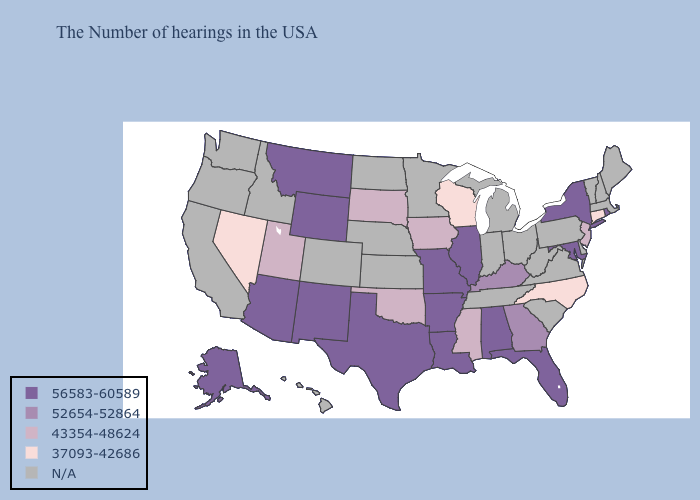Does Oklahoma have the lowest value in the South?
Short answer required. No. Does Arkansas have the highest value in the South?
Quick response, please. Yes. Name the states that have a value in the range 52654-52864?
Write a very short answer. Georgia, Kentucky. Name the states that have a value in the range N/A?
Be succinct. Maine, Massachusetts, New Hampshire, Vermont, Delaware, Pennsylvania, Virginia, South Carolina, West Virginia, Ohio, Michigan, Indiana, Tennessee, Minnesota, Kansas, Nebraska, North Dakota, Colorado, Idaho, California, Washington, Oregon, Hawaii. Name the states that have a value in the range 56583-60589?
Quick response, please. Rhode Island, New York, Maryland, Florida, Alabama, Illinois, Louisiana, Missouri, Arkansas, Texas, Wyoming, New Mexico, Montana, Arizona, Alaska. Among the states that border Alabama , which have the highest value?
Quick response, please. Florida. Name the states that have a value in the range 37093-42686?
Keep it brief. Connecticut, North Carolina, Wisconsin, Nevada. What is the lowest value in states that border Florida?
Keep it brief. 52654-52864. What is the value of Kentucky?
Keep it brief. 52654-52864. What is the value of Florida?
Short answer required. 56583-60589. What is the value of Texas?
Answer briefly. 56583-60589. What is the highest value in states that border Delaware?
Short answer required. 56583-60589. 